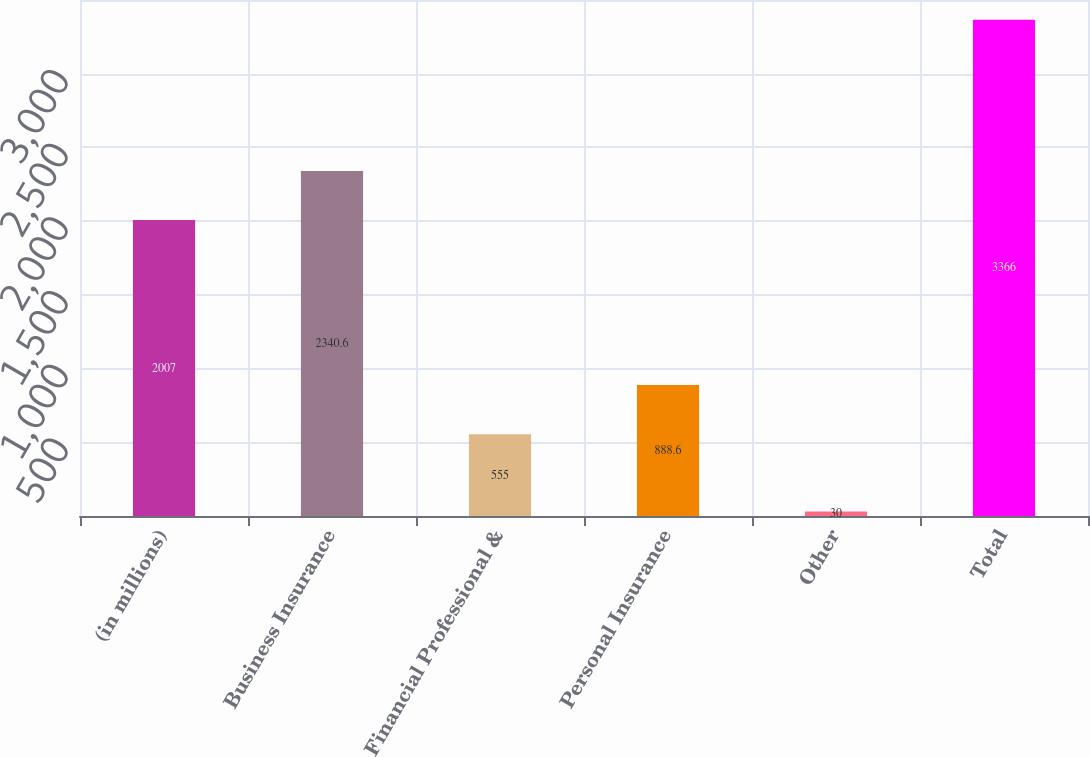<chart> <loc_0><loc_0><loc_500><loc_500><bar_chart><fcel>(in millions)<fcel>Business Insurance<fcel>Financial Professional &<fcel>Personal Insurance<fcel>Other<fcel>Total<nl><fcel>2007<fcel>2340.6<fcel>555<fcel>888.6<fcel>30<fcel>3366<nl></chart> 